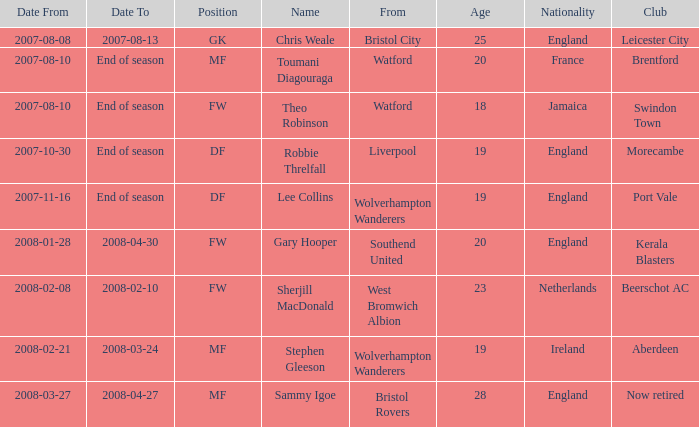Where was the player from who had the position of DF, who started 2007-10-30? Liverpool. 